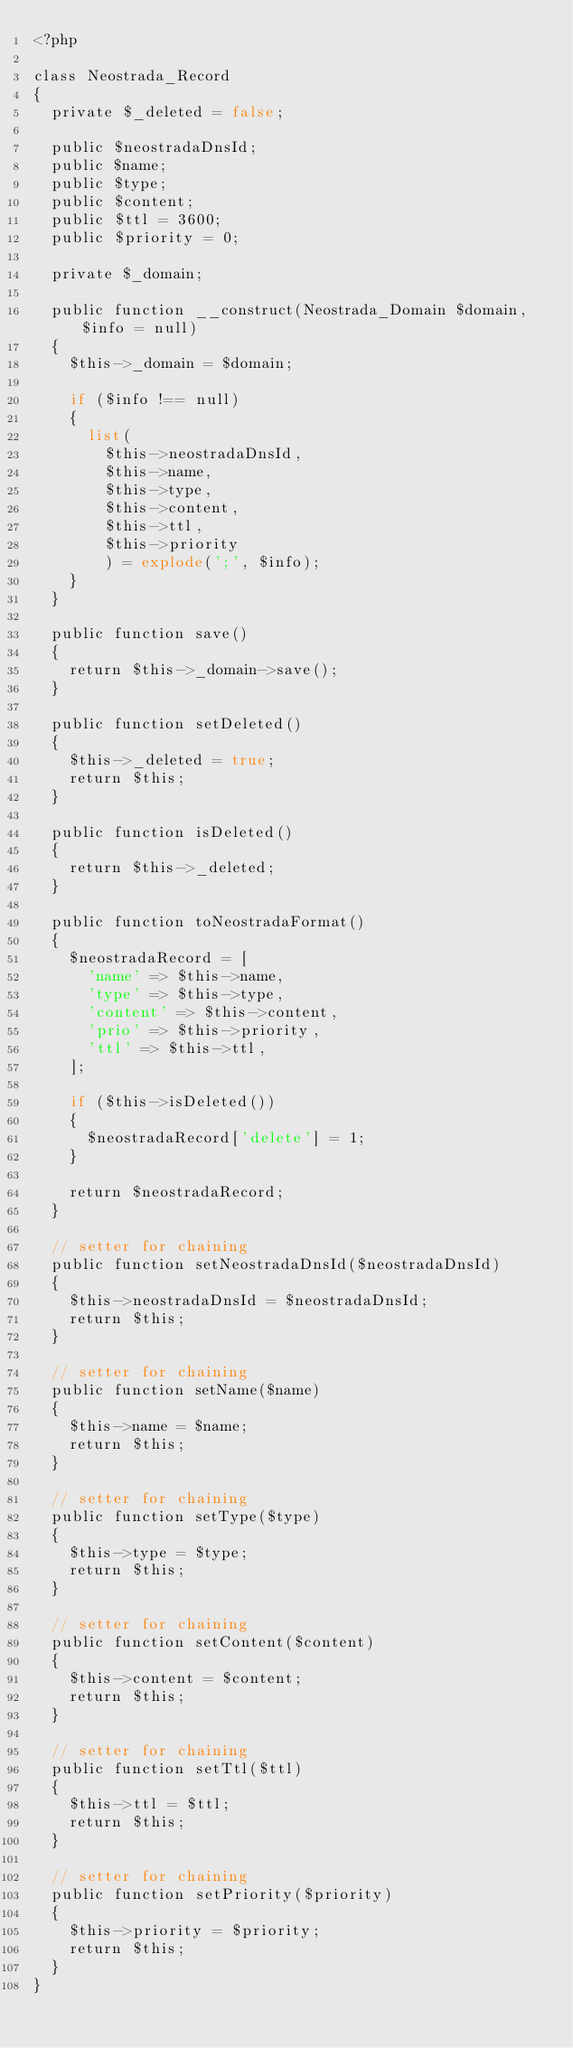<code> <loc_0><loc_0><loc_500><loc_500><_PHP_><?php

class Neostrada_Record
{
	private $_deleted = false;

	public $neostradaDnsId;
	public $name;
	public $type;
	public $content;
	public $ttl = 3600;
	public $priority = 0;

	private $_domain;

	public function __construct(Neostrada_Domain $domain, $info = null)
	{
		$this->_domain = $domain;

		if ($info !== null)
		{
			list(
				$this->neostradaDnsId,
				$this->name,
				$this->type,
				$this->content,
				$this->ttl,
				$this->priority
				) = explode(';', $info);
		}
	}

	public function save()
	{
		return $this->_domain->save();
	}

	public function setDeleted()
	{
		$this->_deleted = true;
		return $this;
	}

	public function isDeleted()
	{
		return $this->_deleted;
	}

	public function toNeostradaFormat()
	{
		$neostradaRecord = [
			'name' => $this->name,
			'type' => $this->type,
			'content' => $this->content,
			'prio' => $this->priority,
			'ttl' => $this->ttl,
		];

		if ($this->isDeleted())
		{
			$neostradaRecord['delete'] = 1;
		}

		return $neostradaRecord;
	}

	// setter for chaining
	public function setNeostradaDnsId($neostradaDnsId)
	{
		$this->neostradaDnsId = $neostradaDnsId;
		return $this;
	}

	// setter for chaining
	public function setName($name)
	{
		$this->name = $name;
		return $this;
	}

	// setter for chaining
	public function setType($type)
	{
		$this->type = $type;
		return $this;
	}

	// setter for chaining
	public function setContent($content)
	{
		$this->content = $content;
		return $this;
	}

	// setter for chaining
	public function setTtl($ttl)
	{
		$this->ttl = $ttl;
		return $this;
	}

	// setter for chaining
	public function setPriority($priority)
	{
		$this->priority = $priority;
		return $this;
	}
}
</code> 